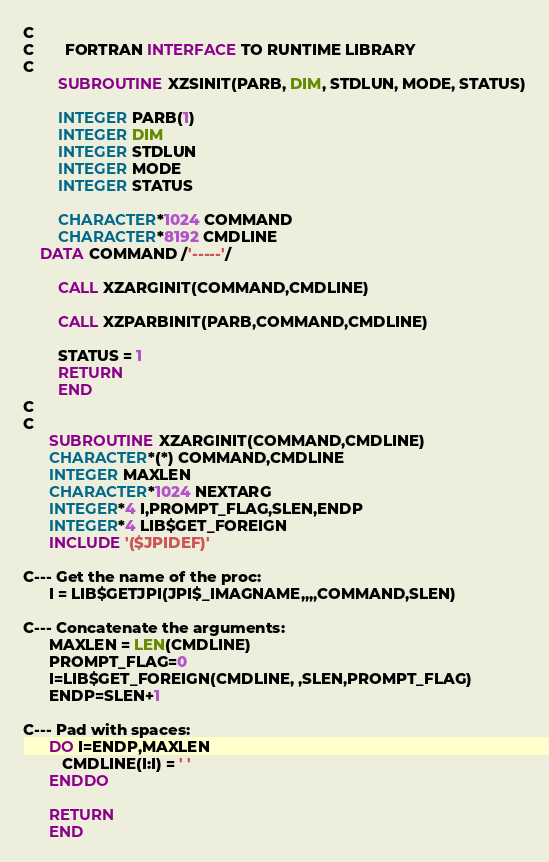<code> <loc_0><loc_0><loc_500><loc_500><_FORTRAN_>C
C       FORTRAN INTERFACE TO RUNTIME LIBRARY
C
        SUBROUTINE XZSINIT(PARB, DIM, STDLUN, MODE, STATUS)

        INTEGER PARB(1)
        INTEGER DIM
        INTEGER STDLUN
        INTEGER MODE
        INTEGER STATUS

        CHARACTER*1024 COMMAND
        CHARACTER*8192 CMDLINE
	DATA COMMAND /'-----'/

        CALL XZARGINIT(COMMAND,CMDLINE)

        CALL XZPARBINIT(PARB,COMMAND,CMDLINE)

        STATUS = 1
        RETURN
        END
C
C
      SUBROUTINE XZARGINIT(COMMAND,CMDLINE)
      CHARACTER*(*) COMMAND,CMDLINE
      INTEGER MAXLEN
      CHARACTER*1024 NEXTARG
      INTEGER*4 I,PROMPT_FLAG,SLEN,ENDP
      INTEGER*4 LIB$GET_FOREIGN
      INCLUDE '($JPIDEF)'

C--- Get the name of the proc:
      I = LIB$GETJPI(JPI$_IMAGNAME,,,,COMMAND,SLEN)

C--- Concatenate the arguments:
      MAXLEN = LEN(CMDLINE)
      PROMPT_FLAG=0
      I=LIB$GET_FOREIGN(CMDLINE, ,SLEN,PROMPT_FLAG)
      ENDP=SLEN+1

C--- Pad with spaces:
      DO I=ENDP,MAXLEN
         CMDLINE(I:I) = ' '
      ENDDO

      RETURN
      END

</code> 